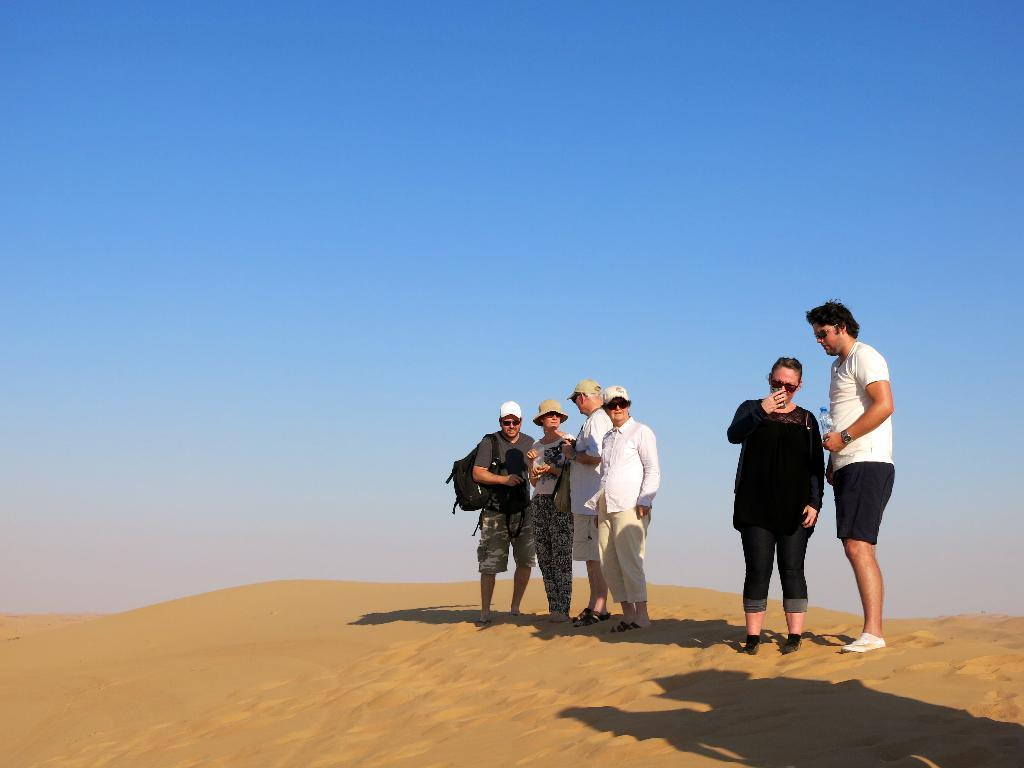Who or what is present in the image? There are people in the image. What are the people wearing on their heads? The people are wearing caps. Where are the people standing? The people are standing on sand. What can be seen in the background of the image? The sky is visible in the background of the image. What is the color of the sky in the image? The sky has a pale blue color. What type of yarn is being used by the people in the image? There is no yarn present in the image; the people are wearing caps. Are there any slaves depicted in the image? There is no mention of slaves in the image, and the term "slave" is not relevant to the content of the image. 